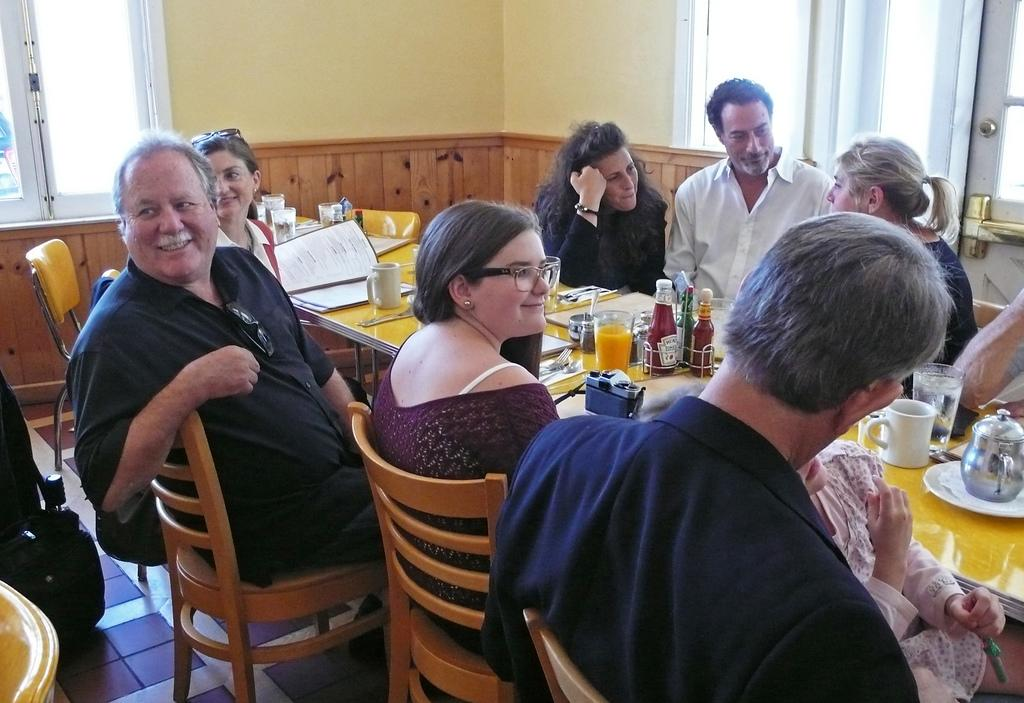Who are the people in the image? The facts provided do not specify the identities of the people in the image. What are the people doing in the image? The people in the image are gathered at a table and talking to each other. What might be the purpose of the gathering? The purpose of the gathering is not specified in the facts provided, but it could be a social event, a meeting, or a meal. What type of love is being expressed between the people in the image? There is no indication of love or affection being expressed between the people in the image; they are simply talking to each other. 